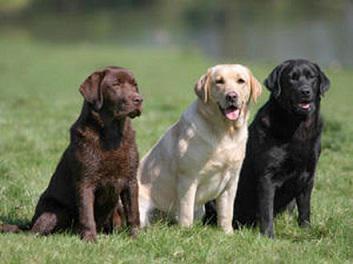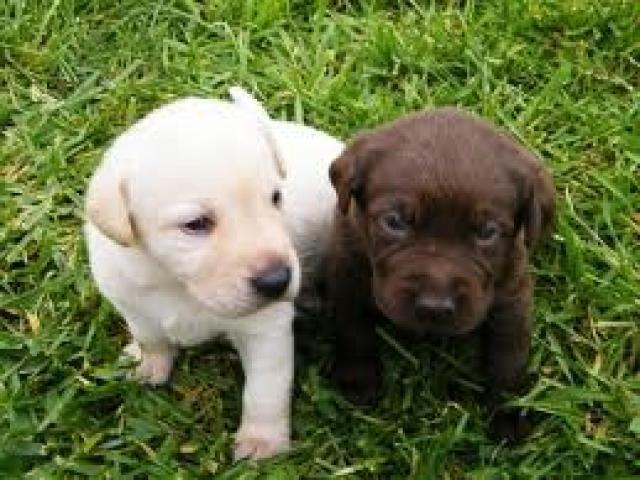The first image is the image on the left, the second image is the image on the right. Analyze the images presented: Is the assertion "A pure white puppy is between a dark brown puppy and a black puppy." valid? Answer yes or no. No. The first image is the image on the left, the second image is the image on the right. Evaluate the accuracy of this statement regarding the images: "There are three dogs sitting on the grass, one black, one brown and one golden.". Is it true? Answer yes or no. No. 